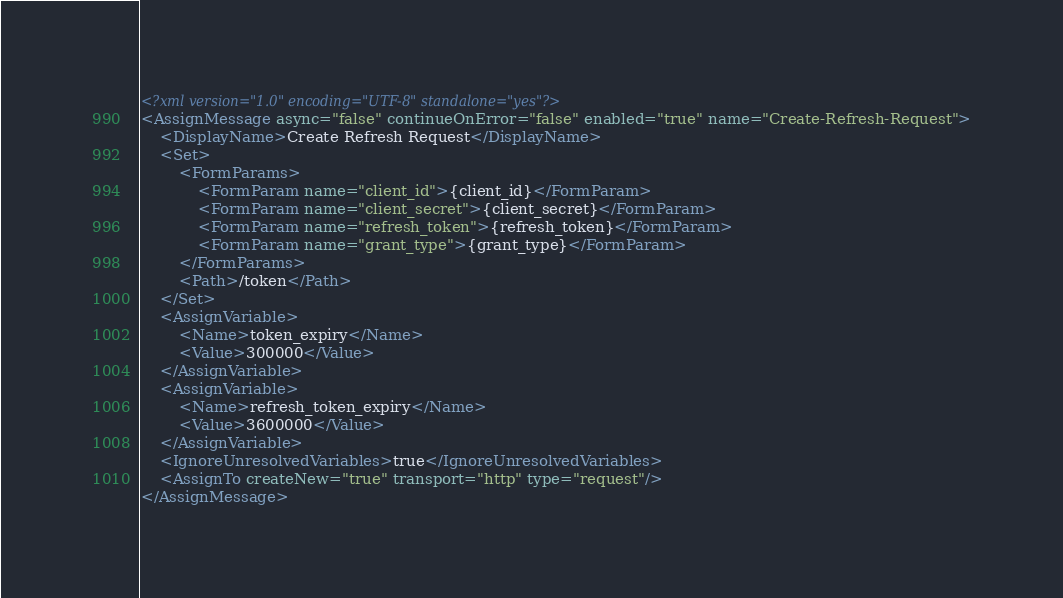Convert code to text. <code><loc_0><loc_0><loc_500><loc_500><_XML_><?xml version="1.0" encoding="UTF-8" standalone="yes"?>
<AssignMessage async="false" continueOnError="false" enabled="true" name="Create-Refresh-Request">
    <DisplayName>Create Refresh Request</DisplayName>
    <Set>
        <FormParams>
            <FormParam name="client_id">{client_id}</FormParam>
            <FormParam name="client_secret">{client_secret}</FormParam>
            <FormParam name="refresh_token">{refresh_token}</FormParam>
            <FormParam name="grant_type">{grant_type}</FormParam>
        </FormParams>
        <Path>/token</Path>
    </Set>
    <AssignVariable>
        <Name>token_expiry</Name>
        <Value>300000</Value>
    </AssignVariable>
    <AssignVariable>
        <Name>refresh_token_expiry</Name>
        <Value>3600000</Value>
    </AssignVariable>
    <IgnoreUnresolvedVariables>true</IgnoreUnresolvedVariables>
    <AssignTo createNew="true" transport="http" type="request"/>
</AssignMessage></code> 